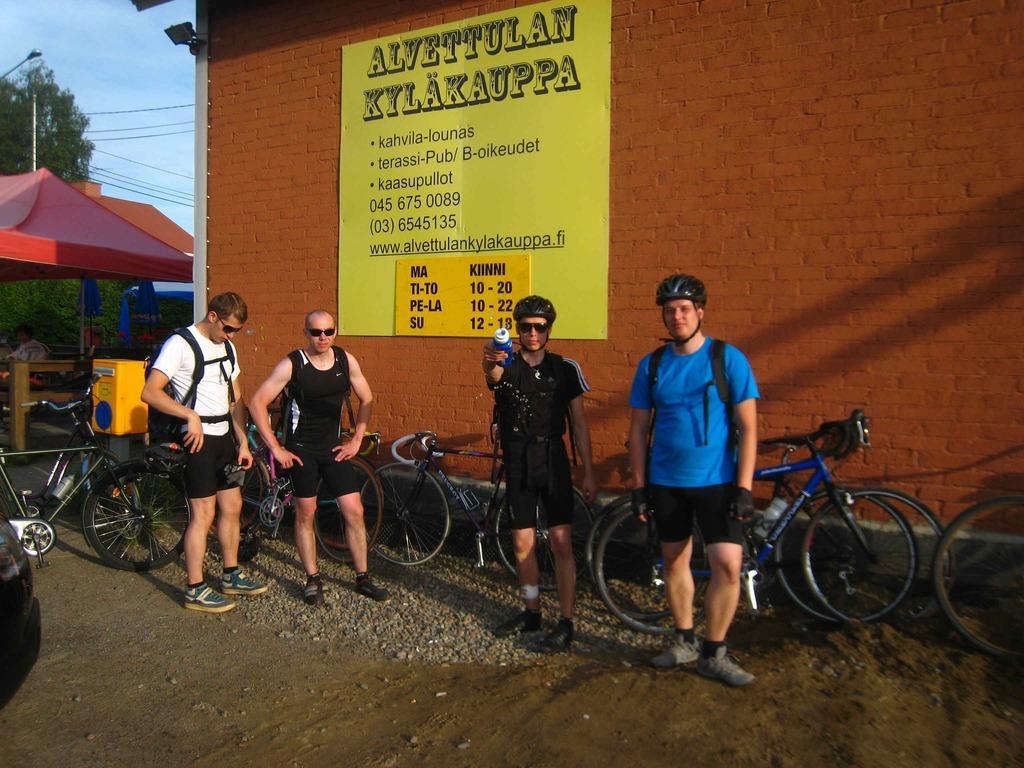Please provide a concise description of this image. In this picture there are four persons standing and there are few bicycles behind them and there is a sheet which has some thing written on it is attached to the wall in the background and there are few other objects and trees in the left corner. 